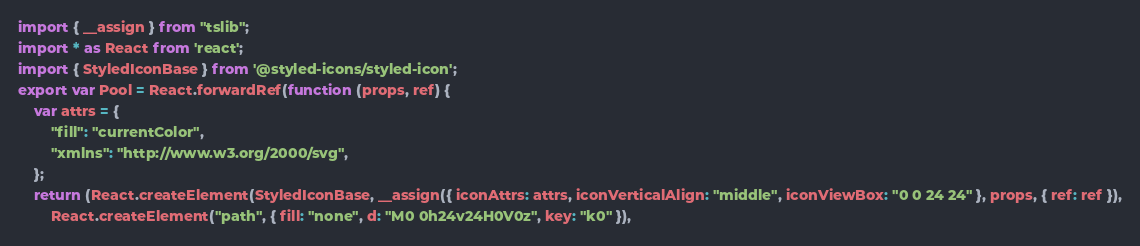Convert code to text. <code><loc_0><loc_0><loc_500><loc_500><_JavaScript_>import { __assign } from "tslib";
import * as React from 'react';
import { StyledIconBase } from '@styled-icons/styled-icon';
export var Pool = React.forwardRef(function (props, ref) {
    var attrs = {
        "fill": "currentColor",
        "xmlns": "http://www.w3.org/2000/svg",
    };
    return (React.createElement(StyledIconBase, __assign({ iconAttrs: attrs, iconVerticalAlign: "middle", iconViewBox: "0 0 24 24" }, props, { ref: ref }),
        React.createElement("path", { fill: "none", d: "M0 0h24v24H0V0z", key: "k0" }),</code> 